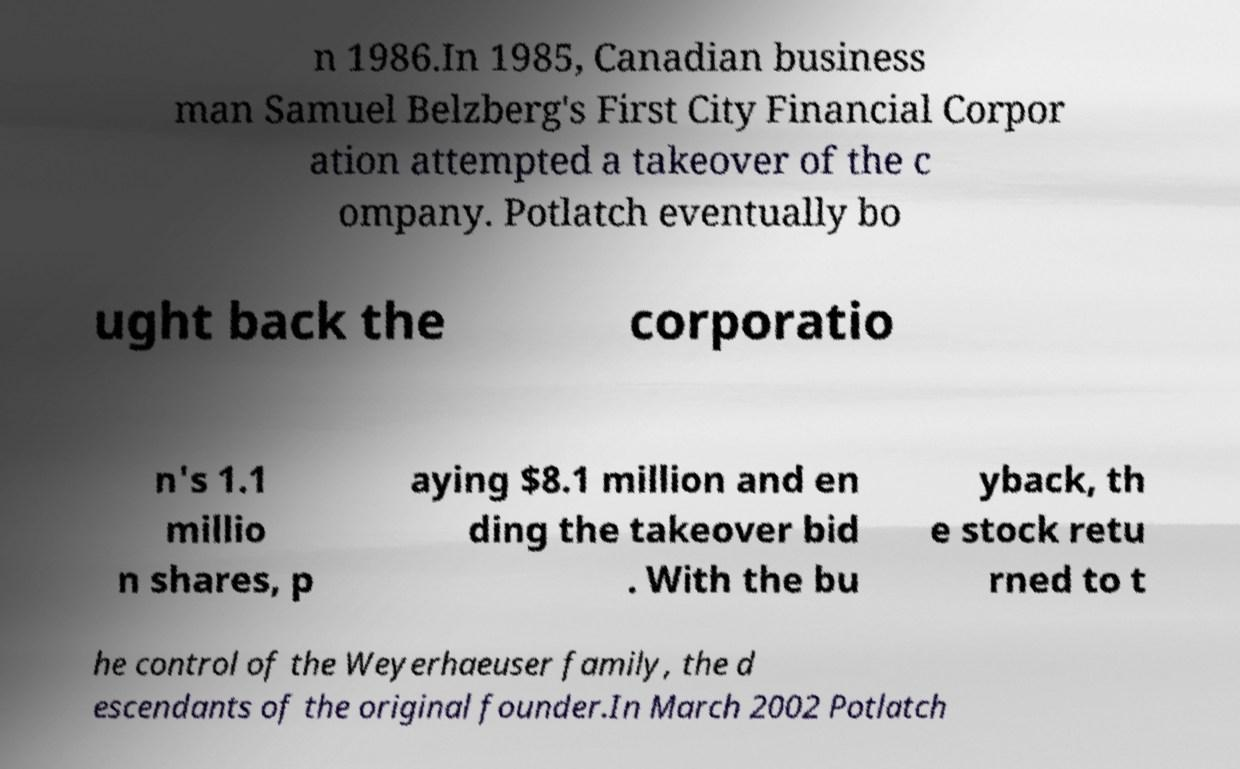I need the written content from this picture converted into text. Can you do that? n 1986.In 1985, Canadian business man Samuel Belzberg's First City Financial Corpor ation attempted a takeover of the c ompany. Potlatch eventually bo ught back the corporatio n's 1.1 millio n shares, p aying $8.1 million and en ding the takeover bid . With the bu yback, th e stock retu rned to t he control of the Weyerhaeuser family, the d escendants of the original founder.In March 2002 Potlatch 